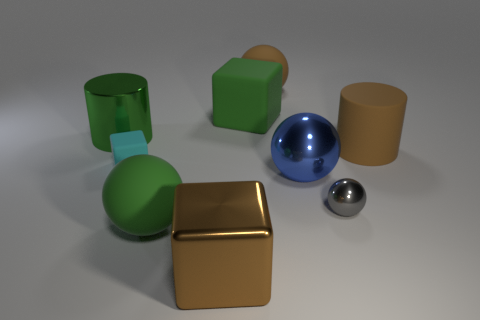What material is the other cylinder that is the same size as the green cylinder?
Provide a succinct answer. Rubber. Are there any small things right of the matte thing that is in front of the small cyan rubber thing?
Your answer should be very brief. Yes. What number of other things are there of the same color as the big metallic cube?
Keep it short and to the point. 2. What is the size of the gray thing?
Keep it short and to the point. Small. Are any large rubber cylinders visible?
Provide a succinct answer. Yes. Is the number of small cyan rubber blocks that are in front of the big metal cylinder greater than the number of shiny cylinders right of the gray metallic ball?
Provide a short and direct response. Yes. There is a object that is both behind the big rubber cylinder and left of the big brown shiny block; what material is it?
Ensure brevity in your answer.  Metal. Is the brown metal thing the same shape as the small cyan thing?
Your answer should be very brief. Yes. There is a gray sphere; how many green matte objects are behind it?
Your answer should be compact. 1. There is a thing on the right side of the gray metallic object; is it the same size as the gray metal thing?
Your answer should be compact. No. 